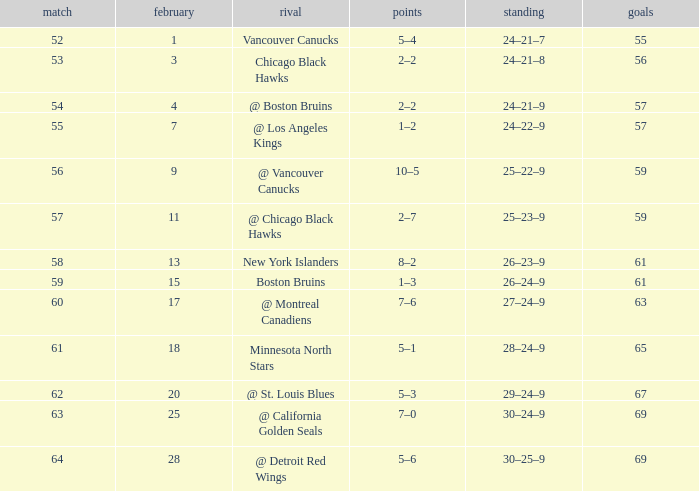How many february games had a record of 29–24–9? 20.0. 